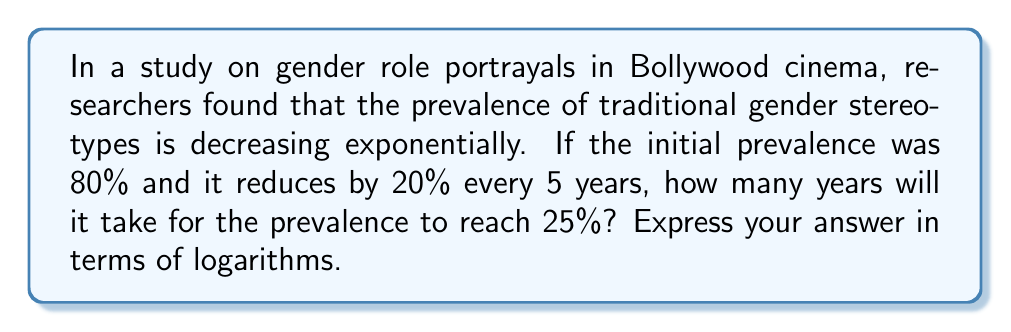Solve this math problem. Let's approach this step-by-step using the exponential decay formula and logarithms:

1) The exponential decay formula is:
   $$A(t) = A_0 \cdot (1-r)^{\frac{t}{k}}$$
   Where:
   $A(t)$ is the amount at time $t$
   $A_0$ is the initial amount
   $r$ is the decay rate per time period
   $k$ is the time period

2) Given:
   $A_0 = 80\%$
   $r = 20\% = 0.2$
   $k = 5$ years
   We want to find $t$ when $A(t) = 25\%$

3) Plugging into the formula:
   $$25 = 80 \cdot (1-0.2)^{\frac{t}{5}}$$

4) Simplify:
   $$25 = 80 \cdot (0.8)^{\frac{t}{5}}$$

5) Divide both sides by 80:
   $$\frac{25}{80} = (0.8)^{\frac{t}{5}}$$

6) Take the natural log of both sides:
   $$\ln(\frac{25}{80}) = \ln((0.8)^{\frac{t}{5}})$$

7) Use the logarithm property $\ln(x^n) = n\ln(x)$:
   $$\ln(\frac{25}{80}) = \frac{t}{5}\ln(0.8)$$

8) Solve for $t$:
   $$t = \frac{5\ln(\frac{25}{80})}{\ln(0.8)}$$

9) This can be simplified using the change of base formula:
   $$t = 5 \cdot \frac{\log_{0.8}(\frac{25}{80})}{1} = 5\log_{0.8}(\frac{25}{80})$$
Answer: $5\log_{0.8}(\frac{25}{80})$ years 